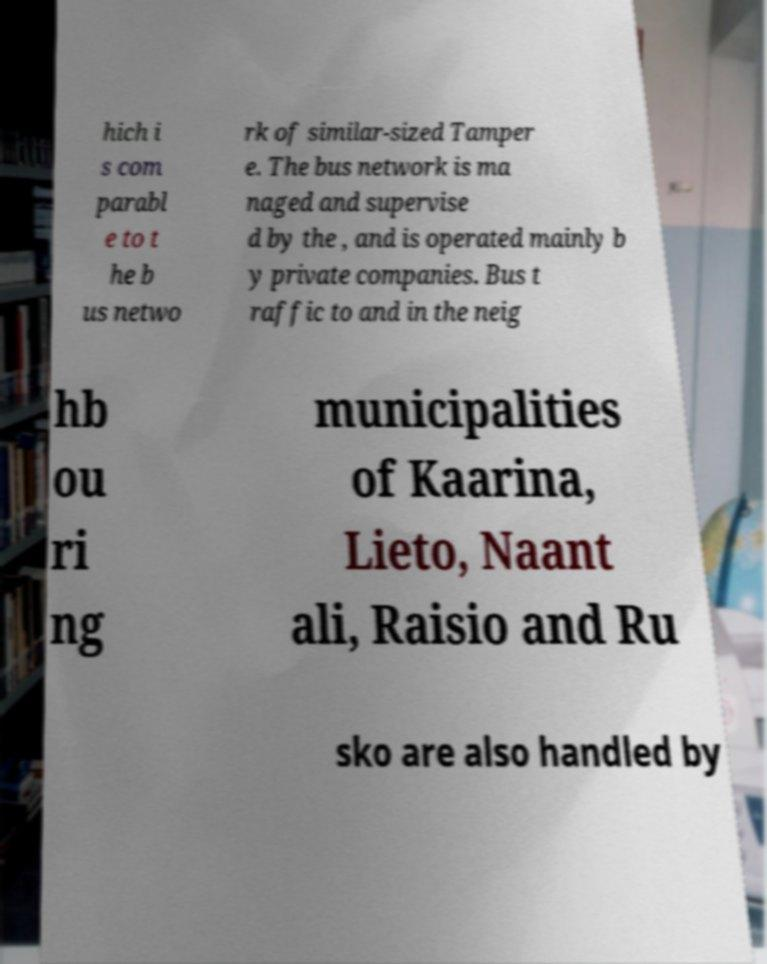Can you read and provide the text displayed in the image?This photo seems to have some interesting text. Can you extract and type it out for me? hich i s com parabl e to t he b us netwo rk of similar-sized Tamper e. The bus network is ma naged and supervise d by the , and is operated mainly b y private companies. Bus t raffic to and in the neig hb ou ri ng municipalities of Kaarina, Lieto, Naant ali, Raisio and Ru sko are also handled by 